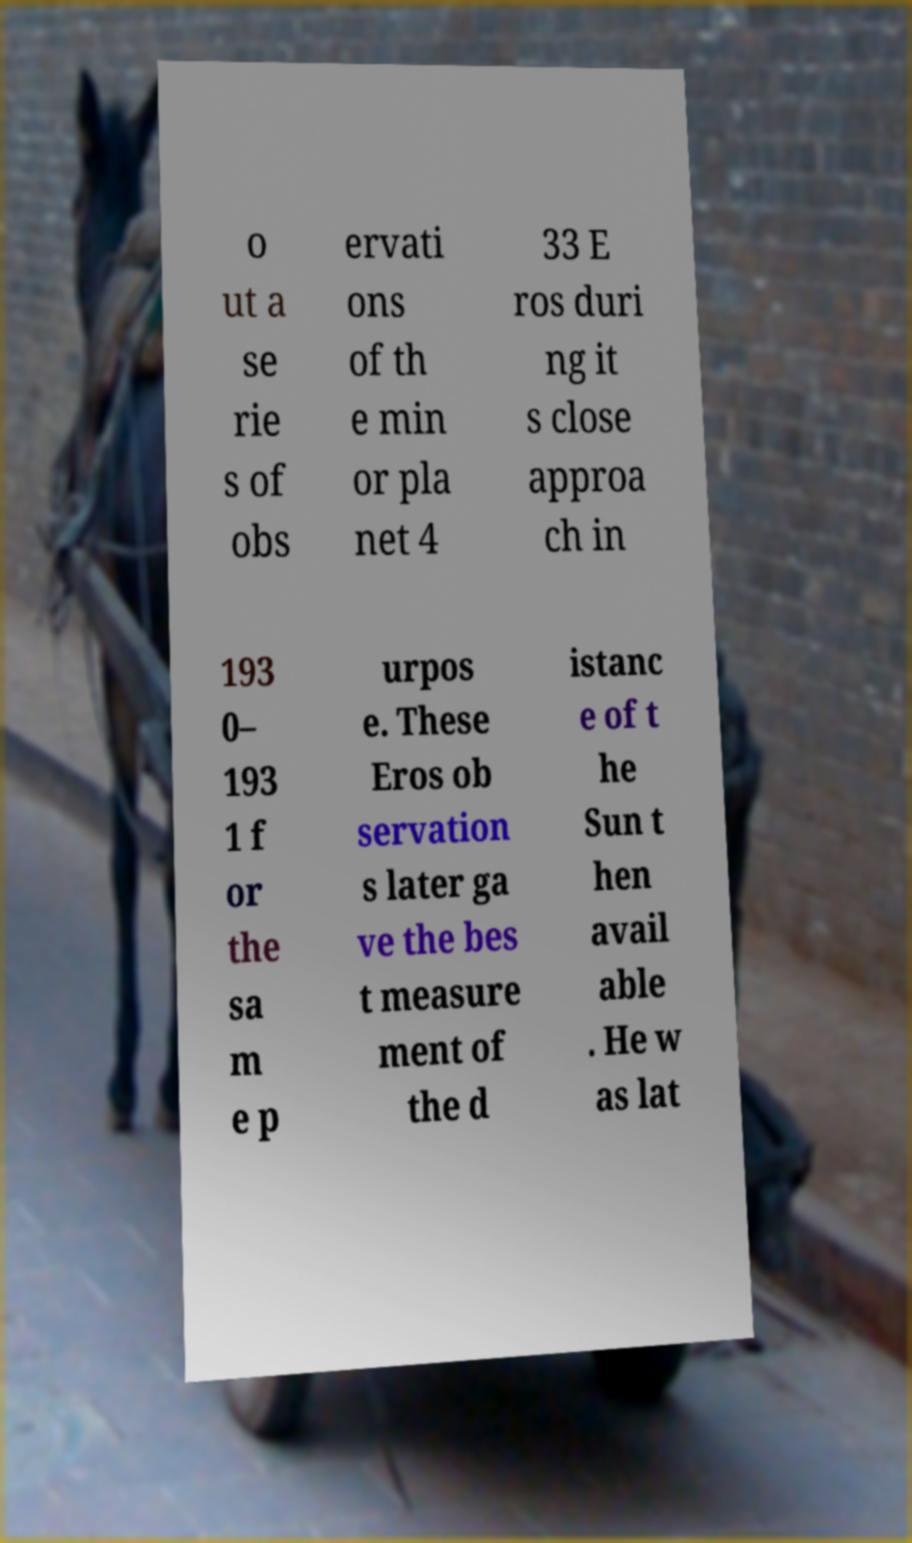There's text embedded in this image that I need extracted. Can you transcribe it verbatim? o ut a se rie s of obs ervati ons of th e min or pla net 4 33 E ros duri ng it s close approa ch in 193 0– 193 1 f or the sa m e p urpos e. These Eros ob servation s later ga ve the bes t measure ment of the d istanc e of t he Sun t hen avail able . He w as lat 